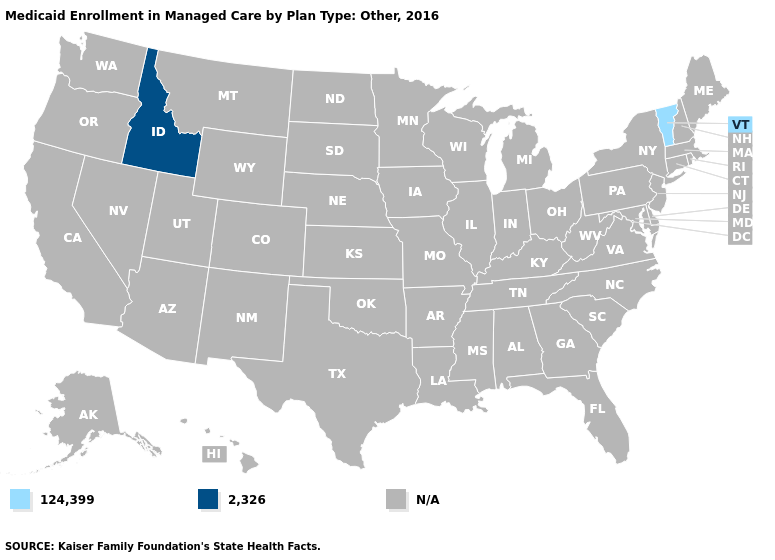What is the value of Colorado?
Concise answer only. N/A. Which states have the highest value in the USA?
Be succinct. Idaho. What is the value of Washington?
Write a very short answer. N/A. What is the lowest value in states that border Wyoming?
Quick response, please. 2,326. What is the lowest value in states that border Nevada?
Give a very brief answer. 2,326. What is the value of Delaware?
Concise answer only. N/A. Is the legend a continuous bar?
Be succinct. No. What is the value of Alabama?
Quick response, please. N/A. Does the map have missing data?
Keep it brief. Yes. What is the value of New Jersey?
Be succinct. N/A. 